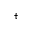Convert formula to latex. <formula><loc_0><loc_0><loc_500><loc_500>^ { \dagger }</formula> 